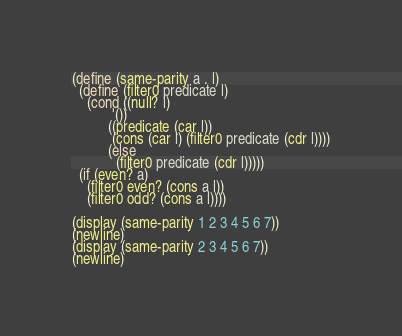Convert code to text. <code><loc_0><loc_0><loc_500><loc_500><_Scheme_>(define (same-parity a . l)
  (define (filter0 predicate l)
    (cond ((null? l)
           '())
          ((predicate (car l))
           (cons (car l) (filter0 predicate (cdr l))))
          (else
            (filter0 predicate (cdr l)))))
  (if (even? a)
    (filter0 even? (cons a l))
    (filter0 odd? (cons a l))))

(display (same-parity 1 2 3 4 5 6 7))
(newline)
(display (same-parity 2 3 4 5 6 7))
(newline)
</code> 